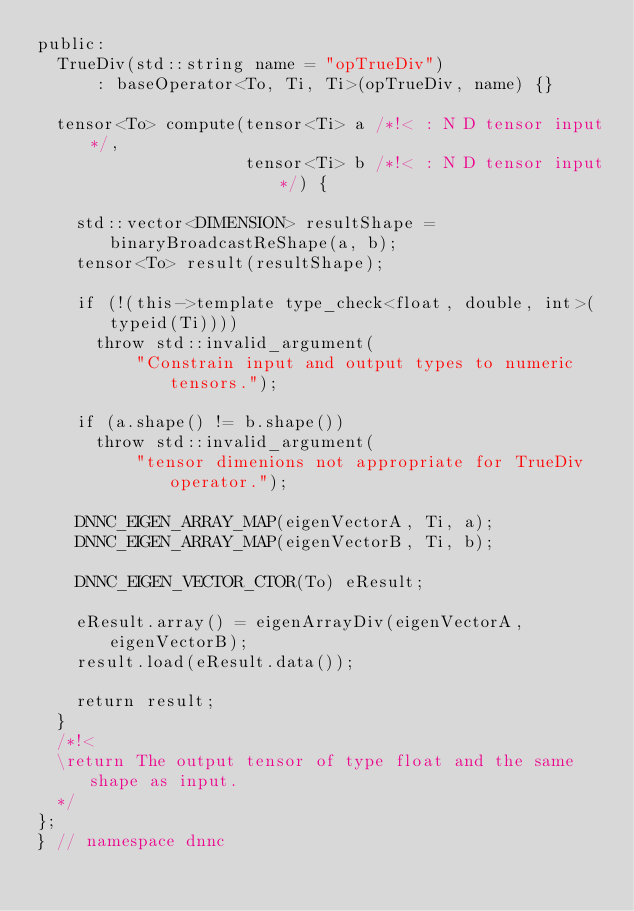Convert code to text. <code><loc_0><loc_0><loc_500><loc_500><_C_>public:
  TrueDiv(std::string name = "opTrueDiv")
      : baseOperator<To, Ti, Ti>(opTrueDiv, name) {}

  tensor<To> compute(tensor<Ti> a /*!< : N D tensor input*/,
                     tensor<Ti> b /*!< : N D tensor input*/) {

    std::vector<DIMENSION> resultShape = binaryBroadcastReShape(a, b);
    tensor<To> result(resultShape);

    if (!(this->template type_check<float, double, int>(typeid(Ti))))
      throw std::invalid_argument(
          "Constrain input and output types to numeric tensors.");

    if (a.shape() != b.shape())
      throw std::invalid_argument(
          "tensor dimenions not appropriate for TrueDiv operator.");

    DNNC_EIGEN_ARRAY_MAP(eigenVectorA, Ti, a);
    DNNC_EIGEN_ARRAY_MAP(eigenVectorB, Ti, b);

    DNNC_EIGEN_VECTOR_CTOR(To) eResult;

    eResult.array() = eigenArrayDiv(eigenVectorA, eigenVectorB);
    result.load(eResult.data());

    return result;
  }
  /*!<
  \return The output tensor of type float and the same shape as input.
  */
};
} // namespace dnnc
</code> 